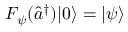Convert formula to latex. <formula><loc_0><loc_0><loc_500><loc_500>F _ { \psi } ( \hat { a } ^ { \dag } ) | 0 \rangle = | \psi \rangle</formula> 